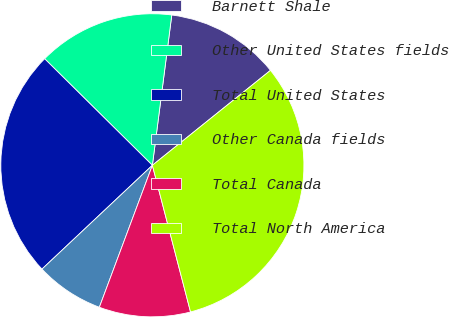Convert chart to OTSL. <chart><loc_0><loc_0><loc_500><loc_500><pie_chart><fcel>Barnett Shale<fcel>Other United States fields<fcel>Total United States<fcel>Other Canada fields<fcel>Total Canada<fcel>Total North America<nl><fcel>12.18%<fcel>14.63%<fcel>24.42%<fcel>7.3%<fcel>9.74%<fcel>31.72%<nl></chart> 